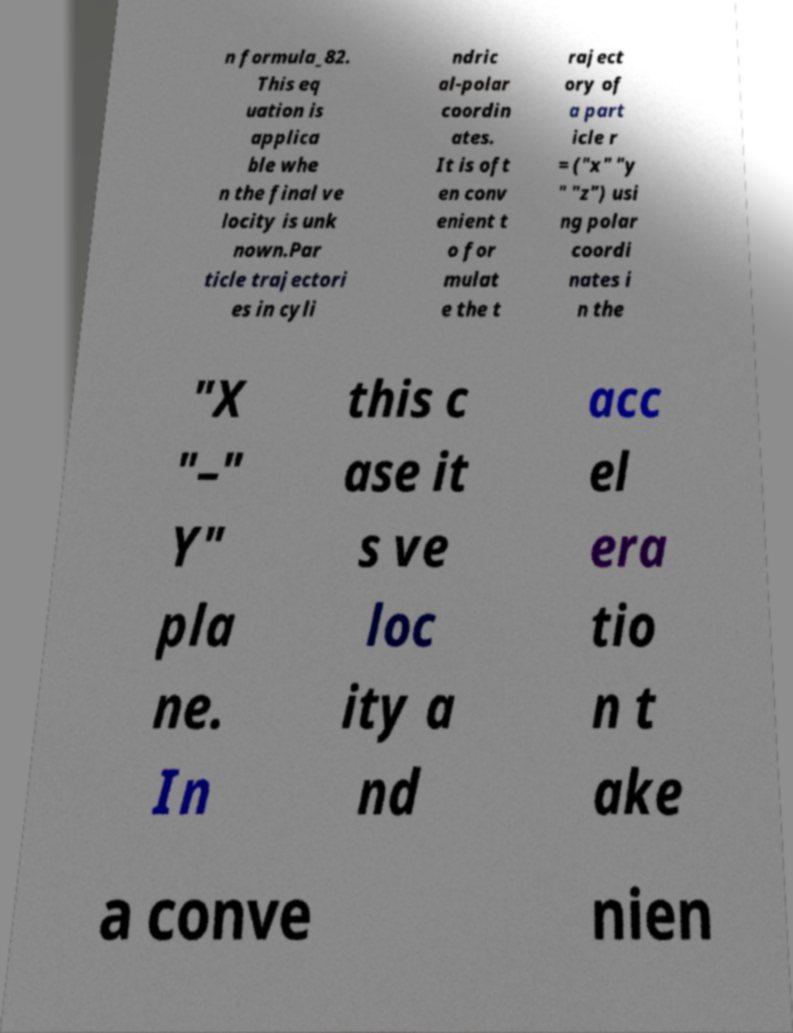For documentation purposes, I need the text within this image transcribed. Could you provide that? n formula_82. This eq uation is applica ble whe n the final ve locity is unk nown.Par ticle trajectori es in cyli ndric al-polar coordin ates. It is oft en conv enient t o for mulat e the t raject ory of a part icle r = ("x" "y " "z") usi ng polar coordi nates i n the "X "–" Y" pla ne. In this c ase it s ve loc ity a nd acc el era tio n t ake a conve nien 